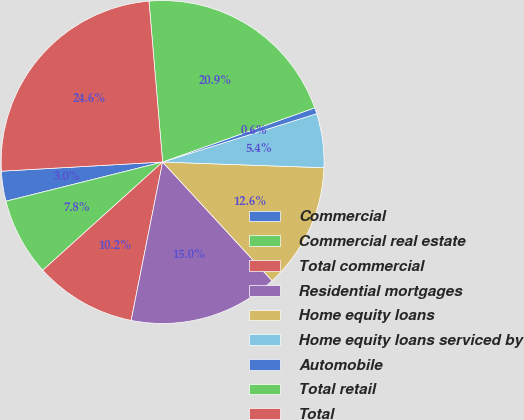Convert chart to OTSL. <chart><loc_0><loc_0><loc_500><loc_500><pie_chart><fcel>Commercial<fcel>Commercial real estate<fcel>Total commercial<fcel>Residential mortgages<fcel>Home equity loans<fcel>Home equity loans serviced by<fcel>Automobile<fcel>Total retail<fcel>Total<nl><fcel>3.0%<fcel>7.79%<fcel>10.19%<fcel>14.98%<fcel>12.58%<fcel>5.4%<fcel>0.61%<fcel>20.9%<fcel>24.56%<nl></chart> 